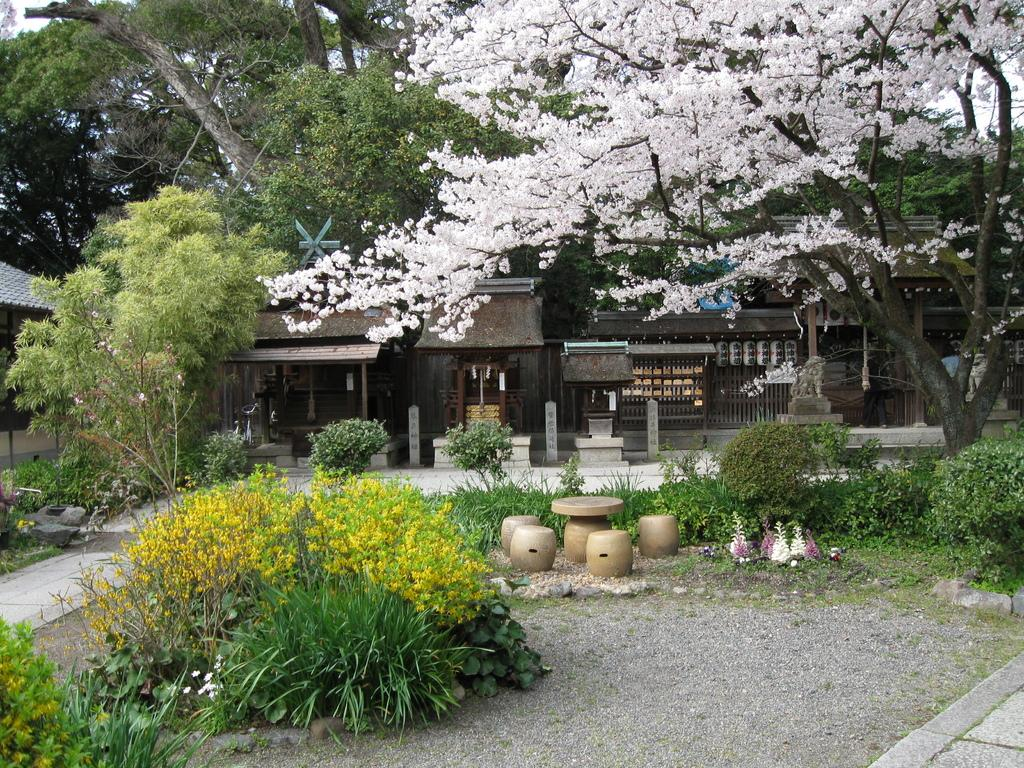What types of natural elements are present in the middle of the image? There are plants and trees in the middle of the image. What types of man-made structures are present in the middle of the image? There are buildings in the middle of the image. What type of meat can be seen hanging from the trees in the image? There is no meat present in the image; it features plants, trees, and buildings. What kind of plot is being developed in the image? The image does not depict a plot or storyline; it is a still image of plants, trees, and buildings. 